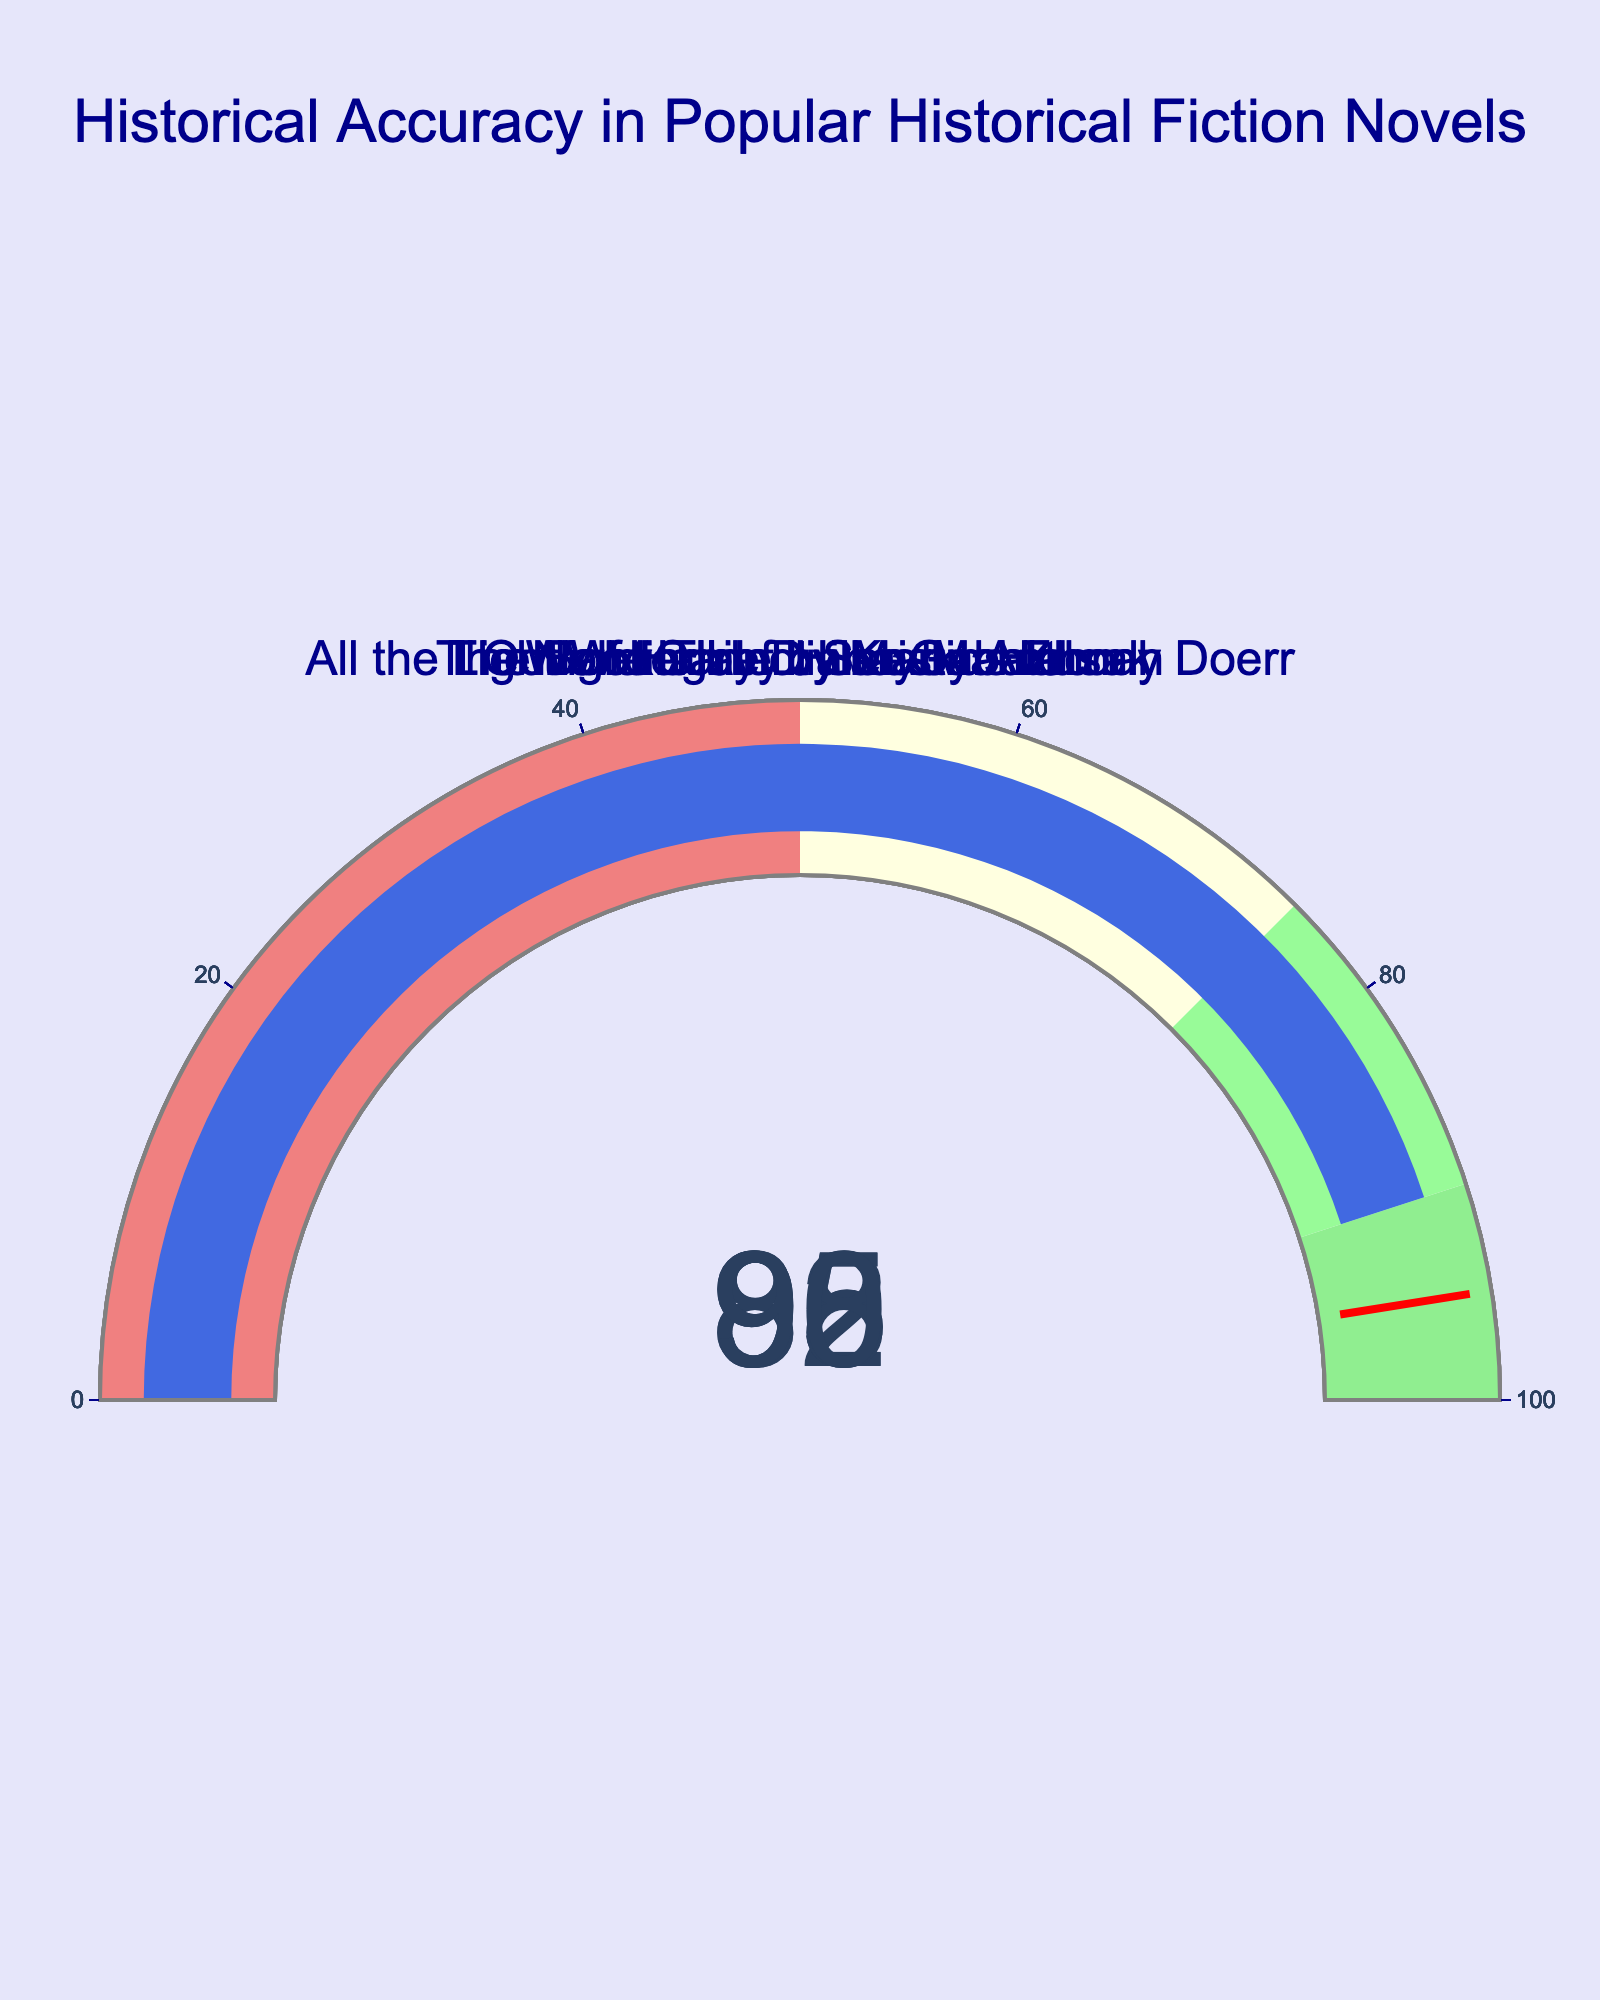what's the title of the figure? The title is usually placed at the top of the figure and helps give an overview of what the chart is about. The title for this specific gauge chart is at the top, center aligned.
Answer: Historical Accuracy in Popular Historical Fiction Novels how many novels are represented in the figure? To determine the number of novels, count the number of individual gauge charts or indicators present. Each gauge represents one novel.
Answer: 5 what color represents the highest accuracy range in the gauge? The highest accuracy range in the gauge is indicated by color coding. The description mentions "lightgreen" for the 90-100 range.
Answer: lightgreen which novel has the highest historical accuracy? Look at the values of historical accuracy on each gauge. "Wolf Hall" by Hilary Mantel has the highest value, which is 95%.
Answer: "Wolf Hall" by Hilary Mantel how does the historical accuracy of "The Nightingale" compare to "Outlander"? Examine the percentage values on the gauge for both novels. "The Nightingale" has an accuracy of 88%, while "Outlander" has 85%. Thus, "The Nightingale" has a higher historical accuracy than "Outlander".
Answer: "The Nightingale" has higher accuracy which novels have an accuracy percentage above 90%? Identify the novels whose gauge show values above 90%. "The Book Thief" by Markus Zusak (92%), "Wolf Hall" by Hilary Mantel (95%), and "All the Light We Cannot See" by Anthony Doerr (90%) fit this criterion.
Answer: "The Book Thief," "Wolf Hall," and "All the Light We Cannot See" what is the difference in historical accuracy between "Outlander" and "All the Light We Cannot See"? Subtract the historical accuracy percentage of "Outlander" (85%) from that of "All the Light We Cannot See" (90%).
Answer: 5% how many novels have accuracy percentages between 85% and 90%? Determine the novels whose accuracy percentages fall between 85% and 90% by examining each gauge. "Outlander" (85%), "The Nightingale" (88%), and "All the Light We Cannot See" (90%) fall in this range.
Answer: 3 what's the average historical accuracy across all novels? Add up the historical accuracy percentages of all novels and divide by the number of novels. (85 + 92 + 95 + 88 + 90) / 5 = 450 / 5.
Answer: 90% what's the most common range of historical accuracy among the novels? Assess the color-coded segments of the gauge representing different ranges and identify where most novels fall. Most novels fall in the range colored "palegreen" for 75-90%.
Answer: 75-90% 